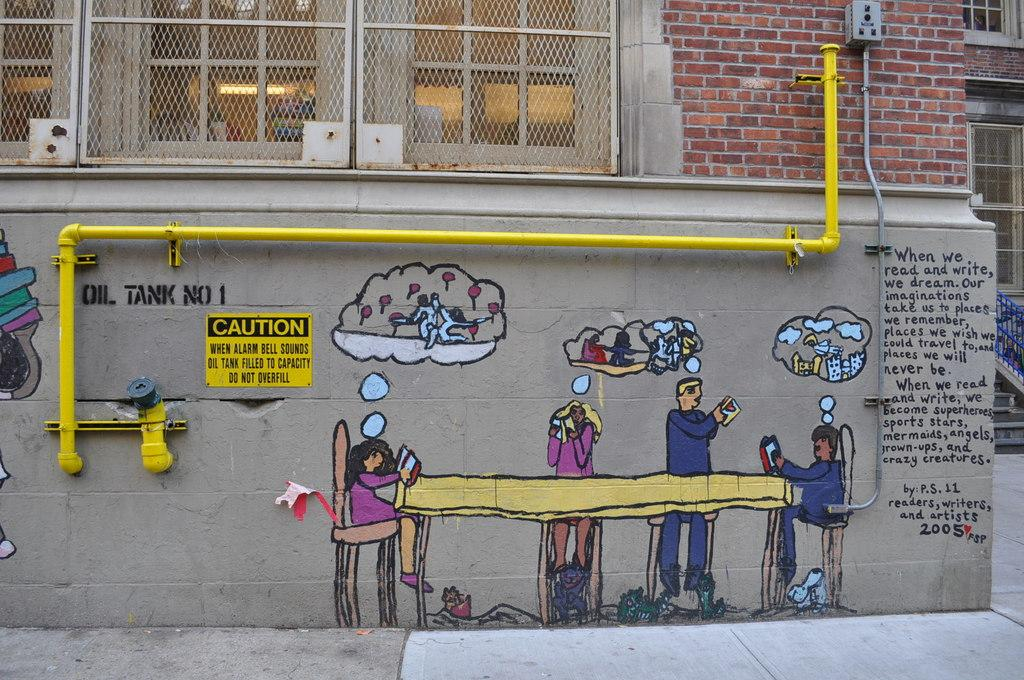What type of structure can be seen in the picture? There is a building in the picture. What decorative element is present on the wall of the building? There is a painting on the wall in the picture. What can be found in addition to the building and painting? There is text visible in the picture. Where is the key located in the picture? There is no key present in the picture. Is there a water fountain visible in the picture? There is no water fountain present in the picture. 